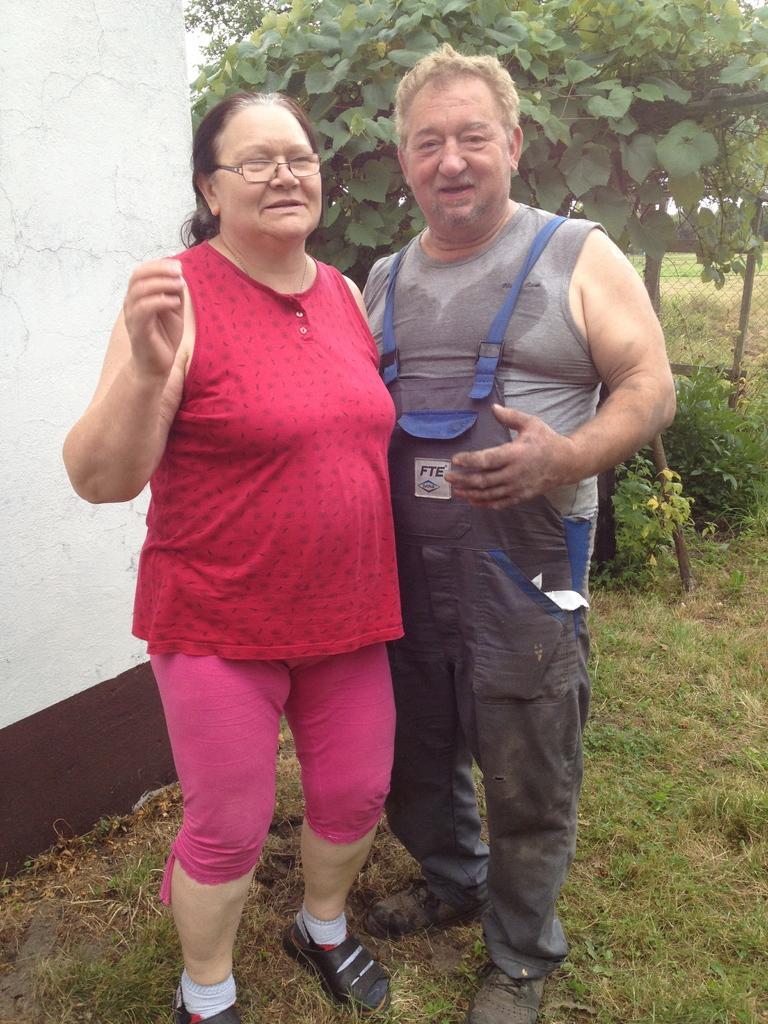Please provide a concise description of this image. In this image we can see a man and a woman standing on the ground. We can also see some grass, a wall, fence and a group of plants. 